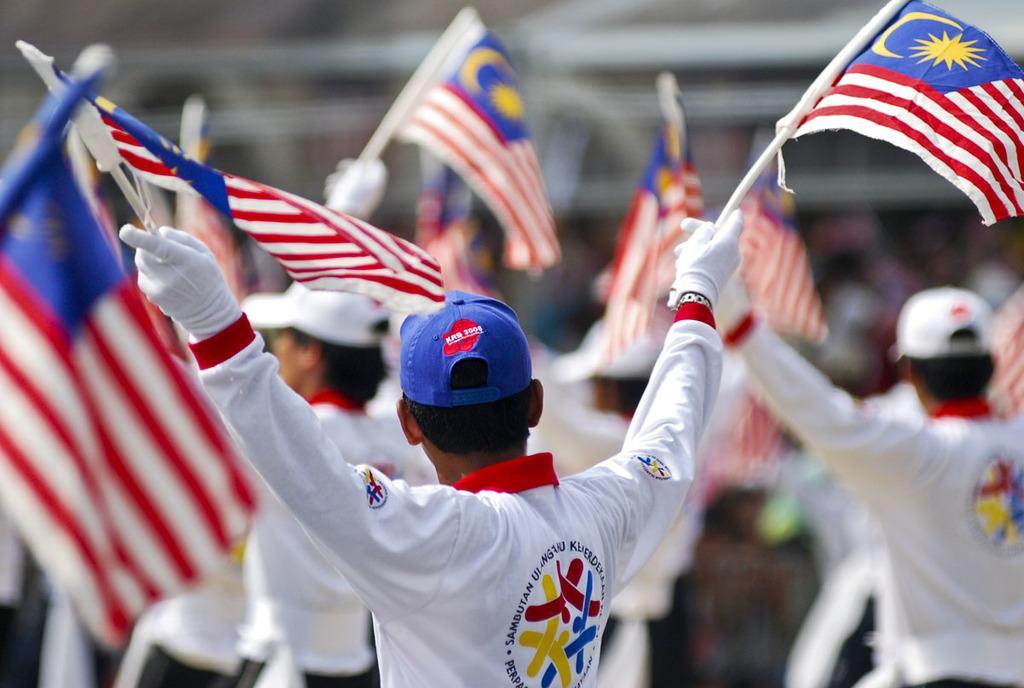Describe this image in one or two sentences. Here we can see people. These people are holding flags. Background it is blur. 